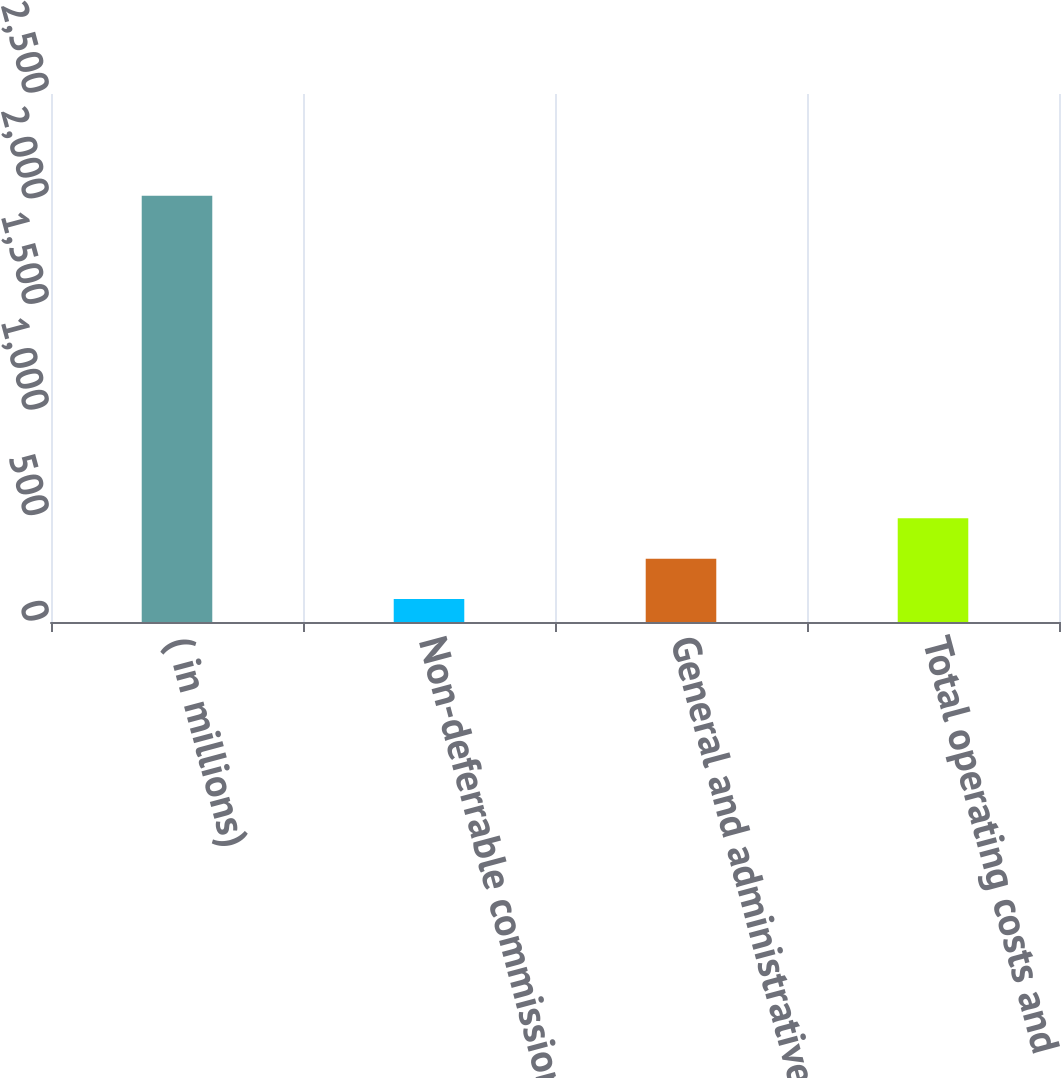<chart> <loc_0><loc_0><loc_500><loc_500><bar_chart><fcel>( in millions)<fcel>Non-deferrable commissions<fcel>General and administrative<fcel>Total operating costs and<nl><fcel>2018<fcel>109<fcel>299.9<fcel>490.8<nl></chart> 